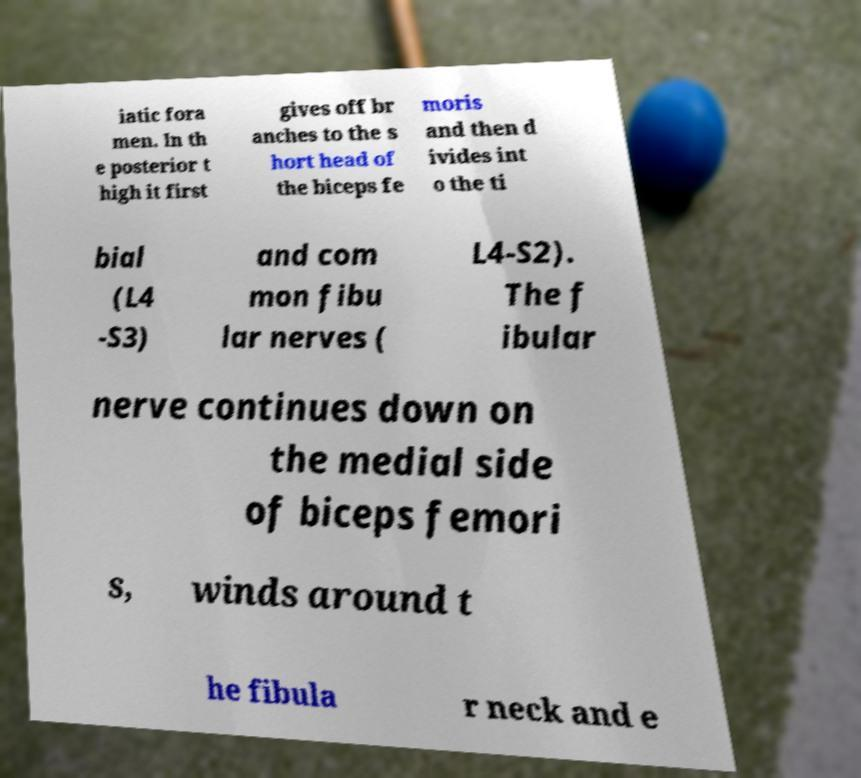Can you read and provide the text displayed in the image?This photo seems to have some interesting text. Can you extract and type it out for me? iatic fora men. In th e posterior t high it first gives off br anches to the s hort head of the biceps fe moris and then d ivides int o the ti bial (L4 -S3) and com mon fibu lar nerves ( L4-S2). The f ibular nerve continues down on the medial side of biceps femori s, winds around t he fibula r neck and e 